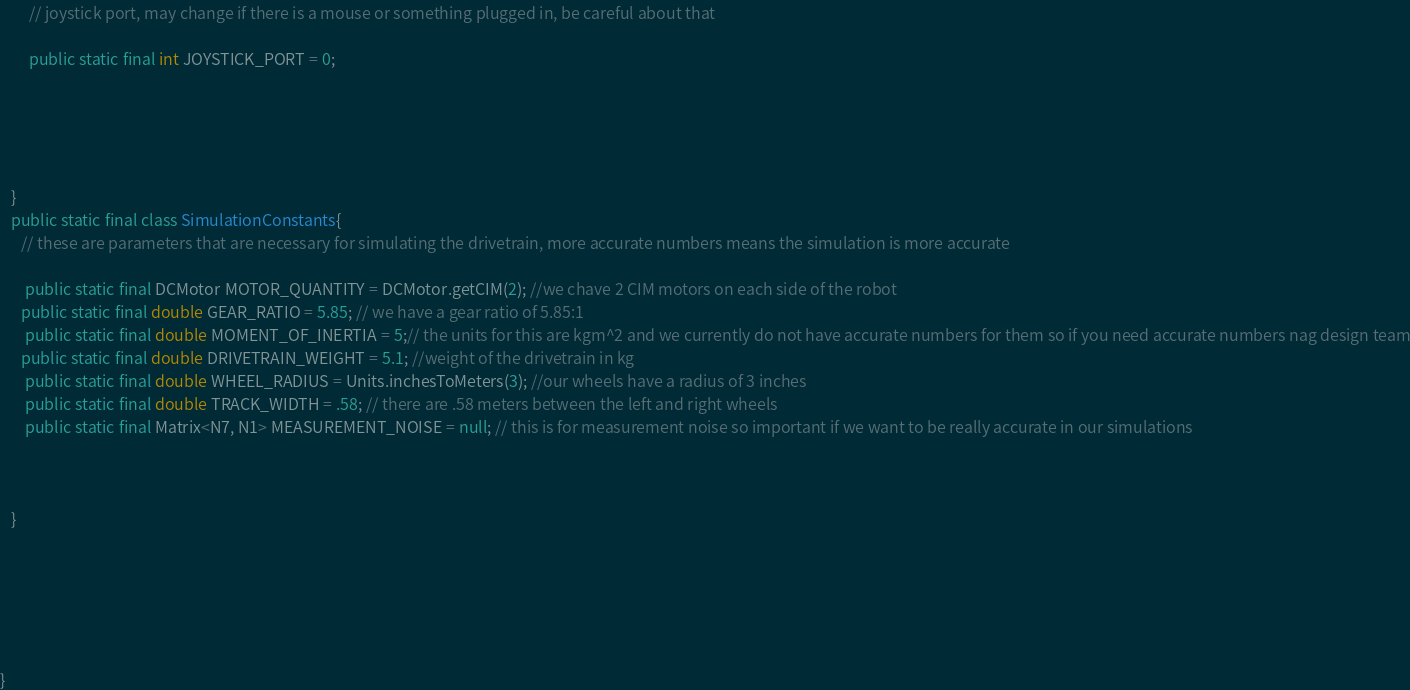<code> <loc_0><loc_0><loc_500><loc_500><_Java_>
        // joystick port, may change if there is a mouse or something plugged in, be careful about that

        public static final int JOYSTICK_PORT = 0;





   }
   public static final class SimulationConstants{
      // these are parameters that are necessary for simulating the drivetrain, more accurate numbers means the simulation is more accurate

	   public static final DCMotor MOTOR_QUANTITY = DCMotor.getCIM(2); //we chave 2 CIM motors on each side of the robot
      public static final double GEAR_RATIO = 5.85; // we have a gear ratio of 5.85:1
	   public static final double MOMENT_OF_INERTIA = 5;// the units for this are kgm^2 and we currently do not have accurate numbers for them so if you need accurate numbers nag design team
      public static final double DRIVETRAIN_WEIGHT = 5.1; //weight of the drivetrain in kg
	   public static final double WHEEL_RADIUS = Units.inchesToMeters(3); //our wheels have a radius of 3 inches
	   public static final double TRACK_WIDTH = .58; // there are .58 meters between the left and right wheels
	   public static final Matrix<N7, N1> MEASUREMENT_NOISE = null; // this is for measurement noise so important if we want to be really accurate in our simulations



   } 






}
</code> 